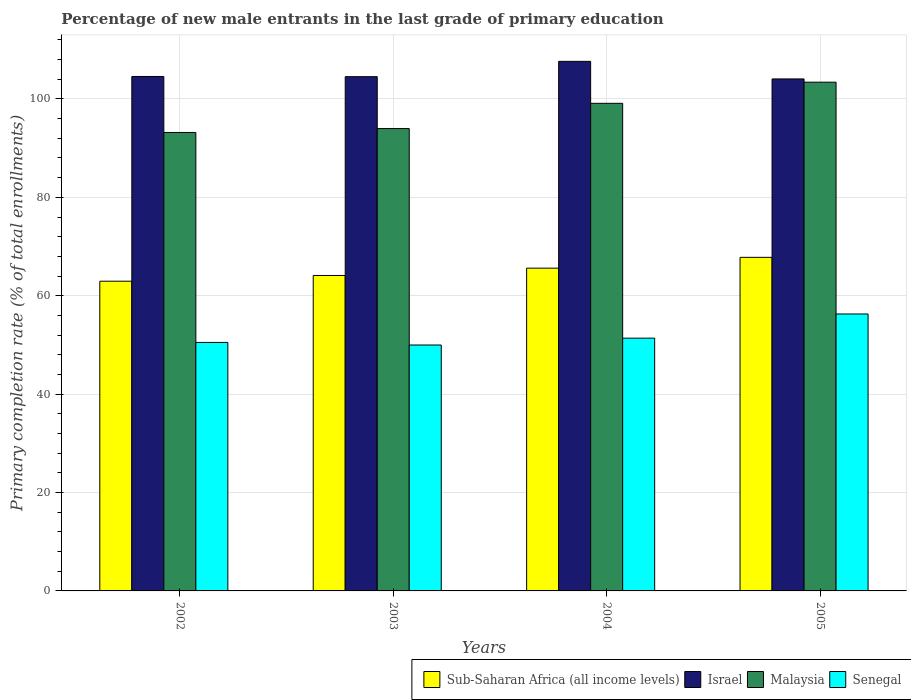How many bars are there on the 1st tick from the left?
Provide a short and direct response. 4. How many bars are there on the 3rd tick from the right?
Give a very brief answer. 4. In how many cases, is the number of bars for a given year not equal to the number of legend labels?
Make the answer very short. 0. What is the percentage of new male entrants in Malaysia in 2005?
Offer a very short reply. 103.41. Across all years, what is the maximum percentage of new male entrants in Malaysia?
Your answer should be very brief. 103.41. Across all years, what is the minimum percentage of new male entrants in Sub-Saharan Africa (all income levels)?
Give a very brief answer. 62.95. What is the total percentage of new male entrants in Sub-Saharan Africa (all income levels) in the graph?
Your answer should be very brief. 260.48. What is the difference between the percentage of new male entrants in Senegal in 2002 and that in 2003?
Keep it short and to the point. 0.52. What is the difference between the percentage of new male entrants in Sub-Saharan Africa (all income levels) in 2005 and the percentage of new male entrants in Malaysia in 2002?
Offer a terse response. -25.39. What is the average percentage of new male entrants in Israel per year?
Provide a succinct answer. 105.2. In the year 2004, what is the difference between the percentage of new male entrants in Senegal and percentage of new male entrants in Malaysia?
Make the answer very short. -47.73. In how many years, is the percentage of new male entrants in Malaysia greater than 92 %?
Keep it short and to the point. 4. What is the ratio of the percentage of new male entrants in Malaysia in 2004 to that in 2005?
Give a very brief answer. 0.96. Is the percentage of new male entrants in Israel in 2003 less than that in 2004?
Your answer should be compact. Yes. Is the difference between the percentage of new male entrants in Senegal in 2003 and 2005 greater than the difference between the percentage of new male entrants in Malaysia in 2003 and 2005?
Keep it short and to the point. Yes. What is the difference between the highest and the second highest percentage of new male entrants in Senegal?
Make the answer very short. 4.91. What is the difference between the highest and the lowest percentage of new male entrants in Israel?
Provide a succinct answer. 3.57. Is it the case that in every year, the sum of the percentage of new male entrants in Sub-Saharan Africa (all income levels) and percentage of new male entrants in Senegal is greater than the sum of percentage of new male entrants in Malaysia and percentage of new male entrants in Israel?
Provide a short and direct response. No. What does the 3rd bar from the left in 2005 represents?
Your answer should be compact. Malaysia. What does the 4th bar from the right in 2002 represents?
Ensure brevity in your answer.  Sub-Saharan Africa (all income levels). Are all the bars in the graph horizontal?
Provide a short and direct response. No. How many years are there in the graph?
Offer a very short reply. 4. What is the difference between two consecutive major ticks on the Y-axis?
Give a very brief answer. 20. Does the graph contain any zero values?
Give a very brief answer. No. Does the graph contain grids?
Make the answer very short. Yes. Where does the legend appear in the graph?
Keep it short and to the point. Bottom right. What is the title of the graph?
Your answer should be compact. Percentage of new male entrants in the last grade of primary education. What is the label or title of the Y-axis?
Provide a short and direct response. Primary completion rate (% of total enrollments). What is the Primary completion rate (% of total enrollments) in Sub-Saharan Africa (all income levels) in 2002?
Provide a succinct answer. 62.95. What is the Primary completion rate (% of total enrollments) in Israel in 2002?
Provide a succinct answer. 104.57. What is the Primary completion rate (% of total enrollments) in Malaysia in 2002?
Ensure brevity in your answer.  93.19. What is the Primary completion rate (% of total enrollments) of Senegal in 2002?
Ensure brevity in your answer.  50.51. What is the Primary completion rate (% of total enrollments) of Sub-Saharan Africa (all income levels) in 2003?
Provide a succinct answer. 64.12. What is the Primary completion rate (% of total enrollments) of Israel in 2003?
Provide a short and direct response. 104.53. What is the Primary completion rate (% of total enrollments) in Malaysia in 2003?
Provide a short and direct response. 93.98. What is the Primary completion rate (% of total enrollments) of Senegal in 2003?
Make the answer very short. 49.99. What is the Primary completion rate (% of total enrollments) of Sub-Saharan Africa (all income levels) in 2004?
Offer a terse response. 65.61. What is the Primary completion rate (% of total enrollments) in Israel in 2004?
Give a very brief answer. 107.64. What is the Primary completion rate (% of total enrollments) of Malaysia in 2004?
Ensure brevity in your answer.  99.11. What is the Primary completion rate (% of total enrollments) in Senegal in 2004?
Your answer should be very brief. 51.38. What is the Primary completion rate (% of total enrollments) in Sub-Saharan Africa (all income levels) in 2005?
Offer a very short reply. 67.8. What is the Primary completion rate (% of total enrollments) in Israel in 2005?
Offer a terse response. 104.07. What is the Primary completion rate (% of total enrollments) in Malaysia in 2005?
Your answer should be compact. 103.41. What is the Primary completion rate (% of total enrollments) in Senegal in 2005?
Keep it short and to the point. 56.29. Across all years, what is the maximum Primary completion rate (% of total enrollments) of Sub-Saharan Africa (all income levels)?
Your response must be concise. 67.8. Across all years, what is the maximum Primary completion rate (% of total enrollments) of Israel?
Provide a short and direct response. 107.64. Across all years, what is the maximum Primary completion rate (% of total enrollments) of Malaysia?
Offer a very short reply. 103.41. Across all years, what is the maximum Primary completion rate (% of total enrollments) of Senegal?
Offer a very short reply. 56.29. Across all years, what is the minimum Primary completion rate (% of total enrollments) in Sub-Saharan Africa (all income levels)?
Provide a short and direct response. 62.95. Across all years, what is the minimum Primary completion rate (% of total enrollments) of Israel?
Offer a terse response. 104.07. Across all years, what is the minimum Primary completion rate (% of total enrollments) in Malaysia?
Offer a very short reply. 93.19. Across all years, what is the minimum Primary completion rate (% of total enrollments) in Senegal?
Offer a terse response. 49.99. What is the total Primary completion rate (% of total enrollments) of Sub-Saharan Africa (all income levels) in the graph?
Provide a short and direct response. 260.48. What is the total Primary completion rate (% of total enrollments) in Israel in the graph?
Offer a very short reply. 420.81. What is the total Primary completion rate (% of total enrollments) of Malaysia in the graph?
Your answer should be compact. 389.69. What is the total Primary completion rate (% of total enrollments) in Senegal in the graph?
Offer a terse response. 208.17. What is the difference between the Primary completion rate (% of total enrollments) of Sub-Saharan Africa (all income levels) in 2002 and that in 2003?
Make the answer very short. -1.17. What is the difference between the Primary completion rate (% of total enrollments) of Israel in 2002 and that in 2003?
Ensure brevity in your answer.  0.04. What is the difference between the Primary completion rate (% of total enrollments) of Malaysia in 2002 and that in 2003?
Provide a short and direct response. -0.79. What is the difference between the Primary completion rate (% of total enrollments) in Senegal in 2002 and that in 2003?
Your answer should be very brief. 0.52. What is the difference between the Primary completion rate (% of total enrollments) in Sub-Saharan Africa (all income levels) in 2002 and that in 2004?
Provide a short and direct response. -2.65. What is the difference between the Primary completion rate (% of total enrollments) of Israel in 2002 and that in 2004?
Offer a very short reply. -3.07. What is the difference between the Primary completion rate (% of total enrollments) in Malaysia in 2002 and that in 2004?
Your answer should be very brief. -5.92. What is the difference between the Primary completion rate (% of total enrollments) of Senegal in 2002 and that in 2004?
Keep it short and to the point. -0.87. What is the difference between the Primary completion rate (% of total enrollments) of Sub-Saharan Africa (all income levels) in 2002 and that in 2005?
Your answer should be very brief. -4.85. What is the difference between the Primary completion rate (% of total enrollments) of Israel in 2002 and that in 2005?
Make the answer very short. 0.5. What is the difference between the Primary completion rate (% of total enrollments) of Malaysia in 2002 and that in 2005?
Keep it short and to the point. -10.22. What is the difference between the Primary completion rate (% of total enrollments) in Senegal in 2002 and that in 2005?
Your answer should be compact. -5.79. What is the difference between the Primary completion rate (% of total enrollments) in Sub-Saharan Africa (all income levels) in 2003 and that in 2004?
Provide a short and direct response. -1.49. What is the difference between the Primary completion rate (% of total enrollments) of Israel in 2003 and that in 2004?
Offer a terse response. -3.12. What is the difference between the Primary completion rate (% of total enrollments) in Malaysia in 2003 and that in 2004?
Your answer should be very brief. -5.13. What is the difference between the Primary completion rate (% of total enrollments) in Senegal in 2003 and that in 2004?
Your response must be concise. -1.39. What is the difference between the Primary completion rate (% of total enrollments) of Sub-Saharan Africa (all income levels) in 2003 and that in 2005?
Your answer should be very brief. -3.68. What is the difference between the Primary completion rate (% of total enrollments) in Israel in 2003 and that in 2005?
Make the answer very short. 0.46. What is the difference between the Primary completion rate (% of total enrollments) of Malaysia in 2003 and that in 2005?
Provide a succinct answer. -9.43. What is the difference between the Primary completion rate (% of total enrollments) in Senegal in 2003 and that in 2005?
Keep it short and to the point. -6.31. What is the difference between the Primary completion rate (% of total enrollments) of Sub-Saharan Africa (all income levels) in 2004 and that in 2005?
Provide a succinct answer. -2.2. What is the difference between the Primary completion rate (% of total enrollments) of Israel in 2004 and that in 2005?
Ensure brevity in your answer.  3.57. What is the difference between the Primary completion rate (% of total enrollments) in Malaysia in 2004 and that in 2005?
Give a very brief answer. -4.3. What is the difference between the Primary completion rate (% of total enrollments) in Senegal in 2004 and that in 2005?
Your answer should be very brief. -4.91. What is the difference between the Primary completion rate (% of total enrollments) in Sub-Saharan Africa (all income levels) in 2002 and the Primary completion rate (% of total enrollments) in Israel in 2003?
Offer a very short reply. -41.57. What is the difference between the Primary completion rate (% of total enrollments) in Sub-Saharan Africa (all income levels) in 2002 and the Primary completion rate (% of total enrollments) in Malaysia in 2003?
Offer a very short reply. -31.03. What is the difference between the Primary completion rate (% of total enrollments) in Sub-Saharan Africa (all income levels) in 2002 and the Primary completion rate (% of total enrollments) in Senegal in 2003?
Ensure brevity in your answer.  12.97. What is the difference between the Primary completion rate (% of total enrollments) in Israel in 2002 and the Primary completion rate (% of total enrollments) in Malaysia in 2003?
Provide a short and direct response. 10.59. What is the difference between the Primary completion rate (% of total enrollments) in Israel in 2002 and the Primary completion rate (% of total enrollments) in Senegal in 2003?
Make the answer very short. 54.58. What is the difference between the Primary completion rate (% of total enrollments) of Malaysia in 2002 and the Primary completion rate (% of total enrollments) of Senegal in 2003?
Offer a very short reply. 43.2. What is the difference between the Primary completion rate (% of total enrollments) of Sub-Saharan Africa (all income levels) in 2002 and the Primary completion rate (% of total enrollments) of Israel in 2004?
Keep it short and to the point. -44.69. What is the difference between the Primary completion rate (% of total enrollments) of Sub-Saharan Africa (all income levels) in 2002 and the Primary completion rate (% of total enrollments) of Malaysia in 2004?
Offer a terse response. -36.16. What is the difference between the Primary completion rate (% of total enrollments) in Sub-Saharan Africa (all income levels) in 2002 and the Primary completion rate (% of total enrollments) in Senegal in 2004?
Keep it short and to the point. 11.57. What is the difference between the Primary completion rate (% of total enrollments) in Israel in 2002 and the Primary completion rate (% of total enrollments) in Malaysia in 2004?
Make the answer very short. 5.46. What is the difference between the Primary completion rate (% of total enrollments) in Israel in 2002 and the Primary completion rate (% of total enrollments) in Senegal in 2004?
Your answer should be very brief. 53.19. What is the difference between the Primary completion rate (% of total enrollments) of Malaysia in 2002 and the Primary completion rate (% of total enrollments) of Senegal in 2004?
Your answer should be very brief. 41.81. What is the difference between the Primary completion rate (% of total enrollments) of Sub-Saharan Africa (all income levels) in 2002 and the Primary completion rate (% of total enrollments) of Israel in 2005?
Keep it short and to the point. -41.12. What is the difference between the Primary completion rate (% of total enrollments) in Sub-Saharan Africa (all income levels) in 2002 and the Primary completion rate (% of total enrollments) in Malaysia in 2005?
Give a very brief answer. -40.46. What is the difference between the Primary completion rate (% of total enrollments) in Sub-Saharan Africa (all income levels) in 2002 and the Primary completion rate (% of total enrollments) in Senegal in 2005?
Keep it short and to the point. 6.66. What is the difference between the Primary completion rate (% of total enrollments) of Israel in 2002 and the Primary completion rate (% of total enrollments) of Malaysia in 2005?
Offer a terse response. 1.16. What is the difference between the Primary completion rate (% of total enrollments) in Israel in 2002 and the Primary completion rate (% of total enrollments) in Senegal in 2005?
Your answer should be compact. 48.28. What is the difference between the Primary completion rate (% of total enrollments) of Malaysia in 2002 and the Primary completion rate (% of total enrollments) of Senegal in 2005?
Keep it short and to the point. 36.9. What is the difference between the Primary completion rate (% of total enrollments) in Sub-Saharan Africa (all income levels) in 2003 and the Primary completion rate (% of total enrollments) in Israel in 2004?
Keep it short and to the point. -43.52. What is the difference between the Primary completion rate (% of total enrollments) in Sub-Saharan Africa (all income levels) in 2003 and the Primary completion rate (% of total enrollments) in Malaysia in 2004?
Your answer should be compact. -34.99. What is the difference between the Primary completion rate (% of total enrollments) in Sub-Saharan Africa (all income levels) in 2003 and the Primary completion rate (% of total enrollments) in Senegal in 2004?
Provide a short and direct response. 12.74. What is the difference between the Primary completion rate (% of total enrollments) of Israel in 2003 and the Primary completion rate (% of total enrollments) of Malaysia in 2004?
Ensure brevity in your answer.  5.41. What is the difference between the Primary completion rate (% of total enrollments) in Israel in 2003 and the Primary completion rate (% of total enrollments) in Senegal in 2004?
Your answer should be compact. 53.15. What is the difference between the Primary completion rate (% of total enrollments) in Malaysia in 2003 and the Primary completion rate (% of total enrollments) in Senegal in 2004?
Offer a terse response. 42.6. What is the difference between the Primary completion rate (% of total enrollments) of Sub-Saharan Africa (all income levels) in 2003 and the Primary completion rate (% of total enrollments) of Israel in 2005?
Offer a terse response. -39.95. What is the difference between the Primary completion rate (% of total enrollments) in Sub-Saharan Africa (all income levels) in 2003 and the Primary completion rate (% of total enrollments) in Malaysia in 2005?
Make the answer very short. -39.29. What is the difference between the Primary completion rate (% of total enrollments) of Sub-Saharan Africa (all income levels) in 2003 and the Primary completion rate (% of total enrollments) of Senegal in 2005?
Provide a succinct answer. 7.82. What is the difference between the Primary completion rate (% of total enrollments) in Israel in 2003 and the Primary completion rate (% of total enrollments) in Malaysia in 2005?
Your response must be concise. 1.12. What is the difference between the Primary completion rate (% of total enrollments) of Israel in 2003 and the Primary completion rate (% of total enrollments) of Senegal in 2005?
Offer a very short reply. 48.23. What is the difference between the Primary completion rate (% of total enrollments) in Malaysia in 2003 and the Primary completion rate (% of total enrollments) in Senegal in 2005?
Give a very brief answer. 37.69. What is the difference between the Primary completion rate (% of total enrollments) of Sub-Saharan Africa (all income levels) in 2004 and the Primary completion rate (% of total enrollments) of Israel in 2005?
Your response must be concise. -38.46. What is the difference between the Primary completion rate (% of total enrollments) in Sub-Saharan Africa (all income levels) in 2004 and the Primary completion rate (% of total enrollments) in Malaysia in 2005?
Your response must be concise. -37.8. What is the difference between the Primary completion rate (% of total enrollments) of Sub-Saharan Africa (all income levels) in 2004 and the Primary completion rate (% of total enrollments) of Senegal in 2005?
Make the answer very short. 9.31. What is the difference between the Primary completion rate (% of total enrollments) in Israel in 2004 and the Primary completion rate (% of total enrollments) in Malaysia in 2005?
Your answer should be compact. 4.23. What is the difference between the Primary completion rate (% of total enrollments) of Israel in 2004 and the Primary completion rate (% of total enrollments) of Senegal in 2005?
Provide a short and direct response. 51.35. What is the difference between the Primary completion rate (% of total enrollments) of Malaysia in 2004 and the Primary completion rate (% of total enrollments) of Senegal in 2005?
Your answer should be very brief. 42.82. What is the average Primary completion rate (% of total enrollments) in Sub-Saharan Africa (all income levels) per year?
Keep it short and to the point. 65.12. What is the average Primary completion rate (% of total enrollments) of Israel per year?
Keep it short and to the point. 105.2. What is the average Primary completion rate (% of total enrollments) in Malaysia per year?
Your answer should be very brief. 97.42. What is the average Primary completion rate (% of total enrollments) in Senegal per year?
Give a very brief answer. 52.04. In the year 2002, what is the difference between the Primary completion rate (% of total enrollments) in Sub-Saharan Africa (all income levels) and Primary completion rate (% of total enrollments) in Israel?
Your response must be concise. -41.62. In the year 2002, what is the difference between the Primary completion rate (% of total enrollments) of Sub-Saharan Africa (all income levels) and Primary completion rate (% of total enrollments) of Malaysia?
Make the answer very short. -30.24. In the year 2002, what is the difference between the Primary completion rate (% of total enrollments) of Sub-Saharan Africa (all income levels) and Primary completion rate (% of total enrollments) of Senegal?
Ensure brevity in your answer.  12.44. In the year 2002, what is the difference between the Primary completion rate (% of total enrollments) of Israel and Primary completion rate (% of total enrollments) of Malaysia?
Keep it short and to the point. 11.38. In the year 2002, what is the difference between the Primary completion rate (% of total enrollments) in Israel and Primary completion rate (% of total enrollments) in Senegal?
Your answer should be compact. 54.06. In the year 2002, what is the difference between the Primary completion rate (% of total enrollments) of Malaysia and Primary completion rate (% of total enrollments) of Senegal?
Provide a short and direct response. 42.68. In the year 2003, what is the difference between the Primary completion rate (% of total enrollments) of Sub-Saharan Africa (all income levels) and Primary completion rate (% of total enrollments) of Israel?
Offer a very short reply. -40.41. In the year 2003, what is the difference between the Primary completion rate (% of total enrollments) of Sub-Saharan Africa (all income levels) and Primary completion rate (% of total enrollments) of Malaysia?
Your answer should be compact. -29.87. In the year 2003, what is the difference between the Primary completion rate (% of total enrollments) in Sub-Saharan Africa (all income levels) and Primary completion rate (% of total enrollments) in Senegal?
Your response must be concise. 14.13. In the year 2003, what is the difference between the Primary completion rate (% of total enrollments) in Israel and Primary completion rate (% of total enrollments) in Malaysia?
Offer a terse response. 10.54. In the year 2003, what is the difference between the Primary completion rate (% of total enrollments) in Israel and Primary completion rate (% of total enrollments) in Senegal?
Give a very brief answer. 54.54. In the year 2003, what is the difference between the Primary completion rate (% of total enrollments) of Malaysia and Primary completion rate (% of total enrollments) of Senegal?
Provide a short and direct response. 44. In the year 2004, what is the difference between the Primary completion rate (% of total enrollments) in Sub-Saharan Africa (all income levels) and Primary completion rate (% of total enrollments) in Israel?
Give a very brief answer. -42.04. In the year 2004, what is the difference between the Primary completion rate (% of total enrollments) in Sub-Saharan Africa (all income levels) and Primary completion rate (% of total enrollments) in Malaysia?
Ensure brevity in your answer.  -33.51. In the year 2004, what is the difference between the Primary completion rate (% of total enrollments) in Sub-Saharan Africa (all income levels) and Primary completion rate (% of total enrollments) in Senegal?
Make the answer very short. 14.23. In the year 2004, what is the difference between the Primary completion rate (% of total enrollments) in Israel and Primary completion rate (% of total enrollments) in Malaysia?
Keep it short and to the point. 8.53. In the year 2004, what is the difference between the Primary completion rate (% of total enrollments) in Israel and Primary completion rate (% of total enrollments) in Senegal?
Your answer should be very brief. 56.26. In the year 2004, what is the difference between the Primary completion rate (% of total enrollments) of Malaysia and Primary completion rate (% of total enrollments) of Senegal?
Your response must be concise. 47.73. In the year 2005, what is the difference between the Primary completion rate (% of total enrollments) in Sub-Saharan Africa (all income levels) and Primary completion rate (% of total enrollments) in Israel?
Your answer should be very brief. -36.27. In the year 2005, what is the difference between the Primary completion rate (% of total enrollments) in Sub-Saharan Africa (all income levels) and Primary completion rate (% of total enrollments) in Malaysia?
Offer a very short reply. -35.61. In the year 2005, what is the difference between the Primary completion rate (% of total enrollments) of Sub-Saharan Africa (all income levels) and Primary completion rate (% of total enrollments) of Senegal?
Your response must be concise. 11.51. In the year 2005, what is the difference between the Primary completion rate (% of total enrollments) of Israel and Primary completion rate (% of total enrollments) of Malaysia?
Provide a short and direct response. 0.66. In the year 2005, what is the difference between the Primary completion rate (% of total enrollments) in Israel and Primary completion rate (% of total enrollments) in Senegal?
Provide a short and direct response. 47.78. In the year 2005, what is the difference between the Primary completion rate (% of total enrollments) in Malaysia and Primary completion rate (% of total enrollments) in Senegal?
Your answer should be compact. 47.12. What is the ratio of the Primary completion rate (% of total enrollments) of Sub-Saharan Africa (all income levels) in 2002 to that in 2003?
Provide a short and direct response. 0.98. What is the ratio of the Primary completion rate (% of total enrollments) in Israel in 2002 to that in 2003?
Provide a succinct answer. 1. What is the ratio of the Primary completion rate (% of total enrollments) in Senegal in 2002 to that in 2003?
Your answer should be compact. 1.01. What is the ratio of the Primary completion rate (% of total enrollments) in Sub-Saharan Africa (all income levels) in 2002 to that in 2004?
Ensure brevity in your answer.  0.96. What is the ratio of the Primary completion rate (% of total enrollments) in Israel in 2002 to that in 2004?
Provide a short and direct response. 0.97. What is the ratio of the Primary completion rate (% of total enrollments) of Malaysia in 2002 to that in 2004?
Provide a succinct answer. 0.94. What is the ratio of the Primary completion rate (% of total enrollments) of Senegal in 2002 to that in 2004?
Ensure brevity in your answer.  0.98. What is the ratio of the Primary completion rate (% of total enrollments) of Sub-Saharan Africa (all income levels) in 2002 to that in 2005?
Ensure brevity in your answer.  0.93. What is the ratio of the Primary completion rate (% of total enrollments) in Malaysia in 2002 to that in 2005?
Your answer should be compact. 0.9. What is the ratio of the Primary completion rate (% of total enrollments) of Senegal in 2002 to that in 2005?
Offer a very short reply. 0.9. What is the ratio of the Primary completion rate (% of total enrollments) in Sub-Saharan Africa (all income levels) in 2003 to that in 2004?
Your answer should be compact. 0.98. What is the ratio of the Primary completion rate (% of total enrollments) of Israel in 2003 to that in 2004?
Ensure brevity in your answer.  0.97. What is the ratio of the Primary completion rate (% of total enrollments) of Malaysia in 2003 to that in 2004?
Provide a short and direct response. 0.95. What is the ratio of the Primary completion rate (% of total enrollments) in Senegal in 2003 to that in 2004?
Your response must be concise. 0.97. What is the ratio of the Primary completion rate (% of total enrollments) of Sub-Saharan Africa (all income levels) in 2003 to that in 2005?
Your response must be concise. 0.95. What is the ratio of the Primary completion rate (% of total enrollments) of Malaysia in 2003 to that in 2005?
Give a very brief answer. 0.91. What is the ratio of the Primary completion rate (% of total enrollments) of Senegal in 2003 to that in 2005?
Your response must be concise. 0.89. What is the ratio of the Primary completion rate (% of total enrollments) of Sub-Saharan Africa (all income levels) in 2004 to that in 2005?
Your answer should be very brief. 0.97. What is the ratio of the Primary completion rate (% of total enrollments) in Israel in 2004 to that in 2005?
Keep it short and to the point. 1.03. What is the ratio of the Primary completion rate (% of total enrollments) of Malaysia in 2004 to that in 2005?
Keep it short and to the point. 0.96. What is the ratio of the Primary completion rate (% of total enrollments) in Senegal in 2004 to that in 2005?
Offer a very short reply. 0.91. What is the difference between the highest and the second highest Primary completion rate (% of total enrollments) of Sub-Saharan Africa (all income levels)?
Offer a terse response. 2.2. What is the difference between the highest and the second highest Primary completion rate (% of total enrollments) of Israel?
Make the answer very short. 3.07. What is the difference between the highest and the second highest Primary completion rate (% of total enrollments) of Malaysia?
Provide a short and direct response. 4.3. What is the difference between the highest and the second highest Primary completion rate (% of total enrollments) of Senegal?
Give a very brief answer. 4.91. What is the difference between the highest and the lowest Primary completion rate (% of total enrollments) in Sub-Saharan Africa (all income levels)?
Your answer should be compact. 4.85. What is the difference between the highest and the lowest Primary completion rate (% of total enrollments) in Israel?
Your response must be concise. 3.57. What is the difference between the highest and the lowest Primary completion rate (% of total enrollments) of Malaysia?
Offer a terse response. 10.22. What is the difference between the highest and the lowest Primary completion rate (% of total enrollments) in Senegal?
Offer a very short reply. 6.31. 